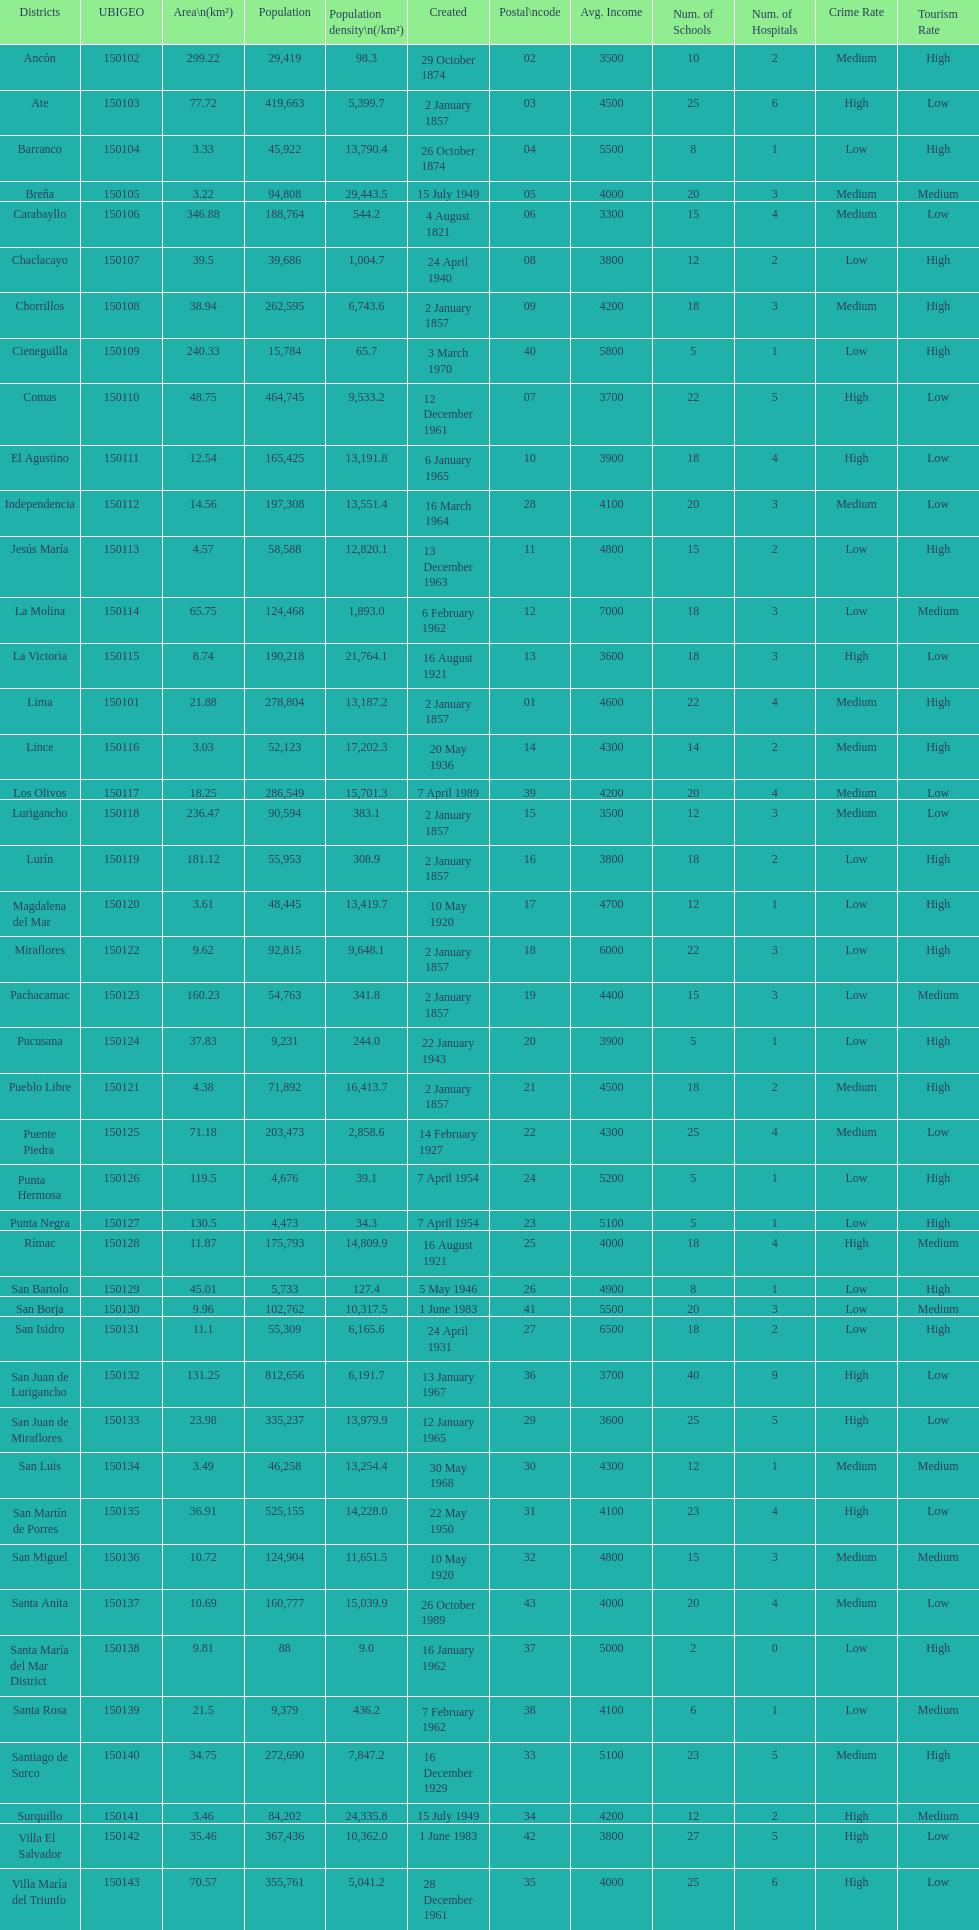How many districts are there in this city? 43. 